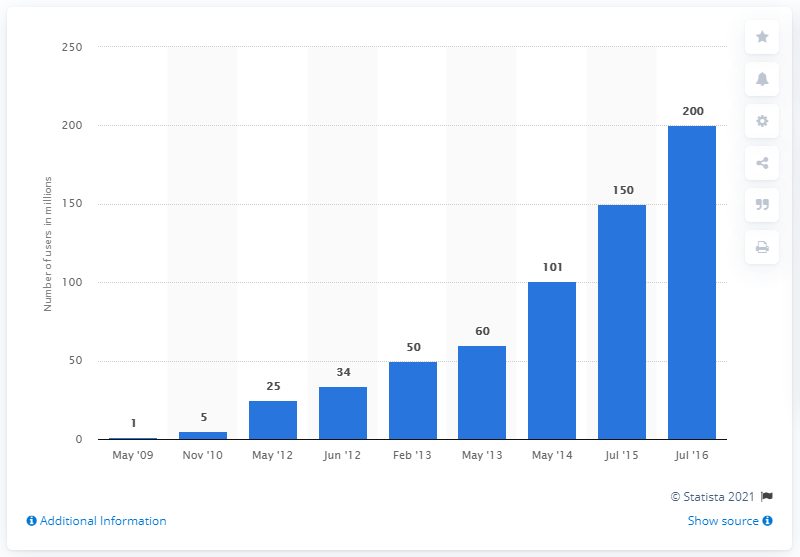Specify some key components in this picture. As of July 2016, Evernote had approximately 200 users. In May 2009, the number of registered Evernote users was the lowest among all months. As of May 2012, there were 175 registered Evernote users. In July 2016, there were 175 registered Evernote users. 